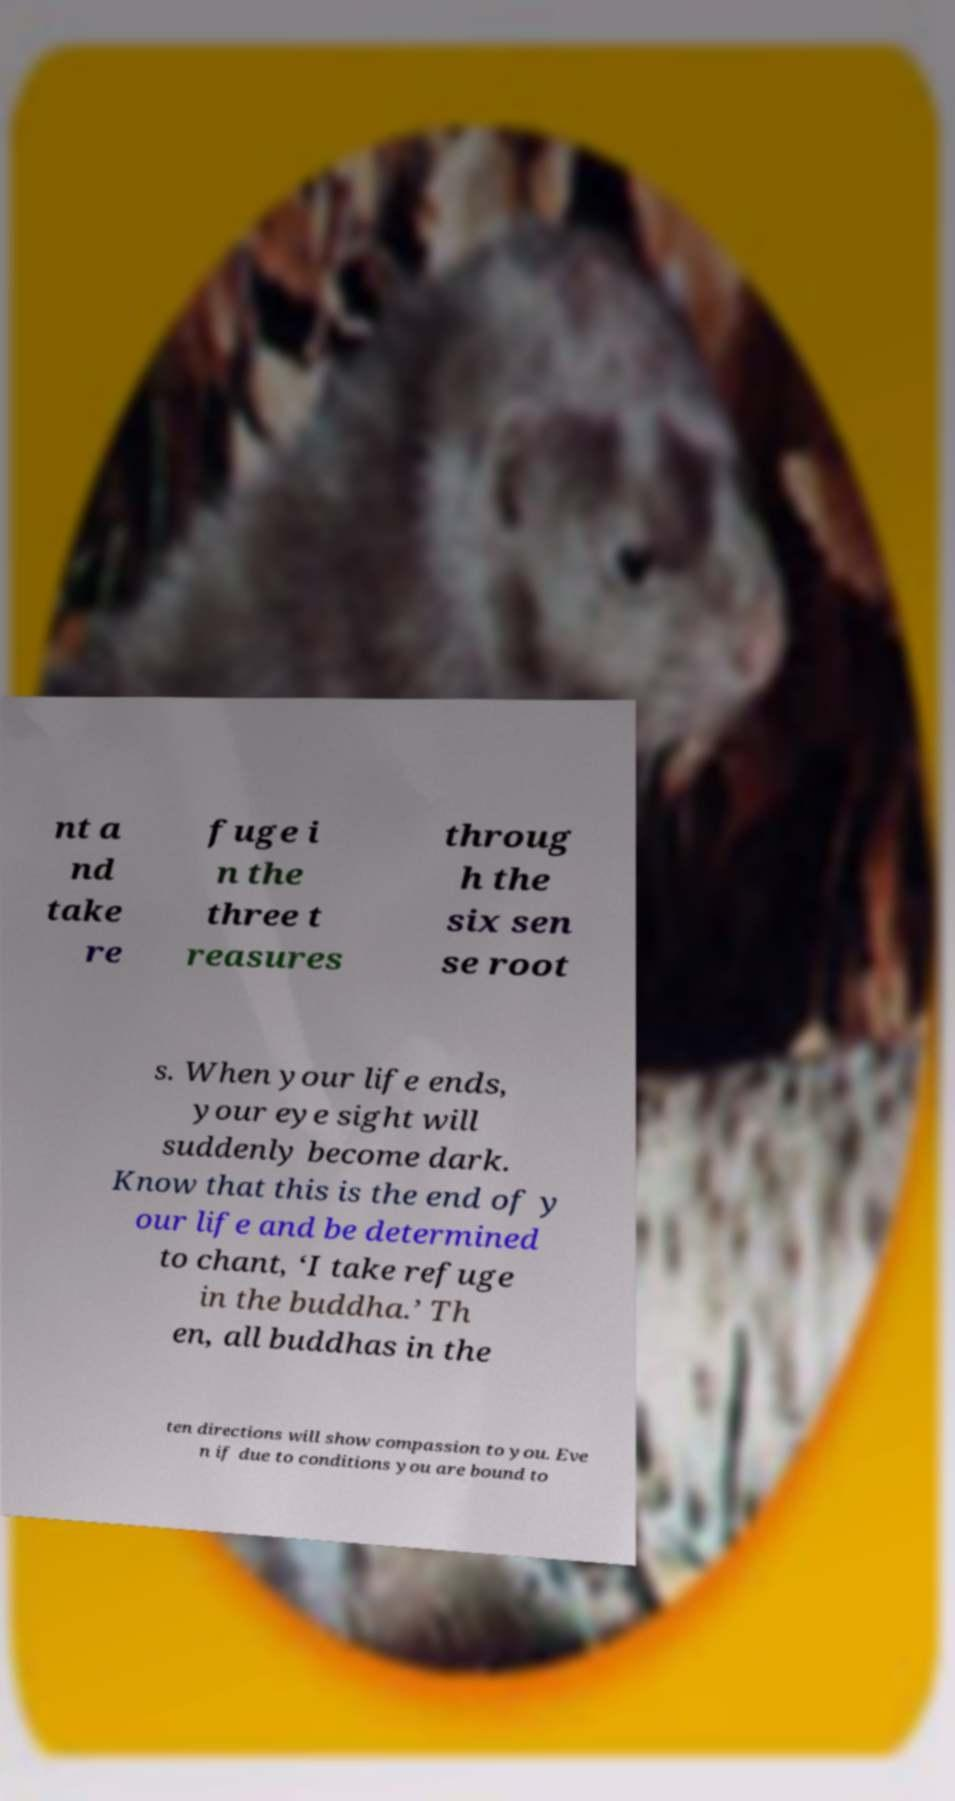For documentation purposes, I need the text within this image transcribed. Could you provide that? nt a nd take re fuge i n the three t reasures throug h the six sen se root s. When your life ends, your eye sight will suddenly become dark. Know that this is the end of y our life and be determined to chant, ‘I take refuge in the buddha.’ Th en, all buddhas in the ten directions will show compassion to you. Eve n if due to conditions you are bound to 